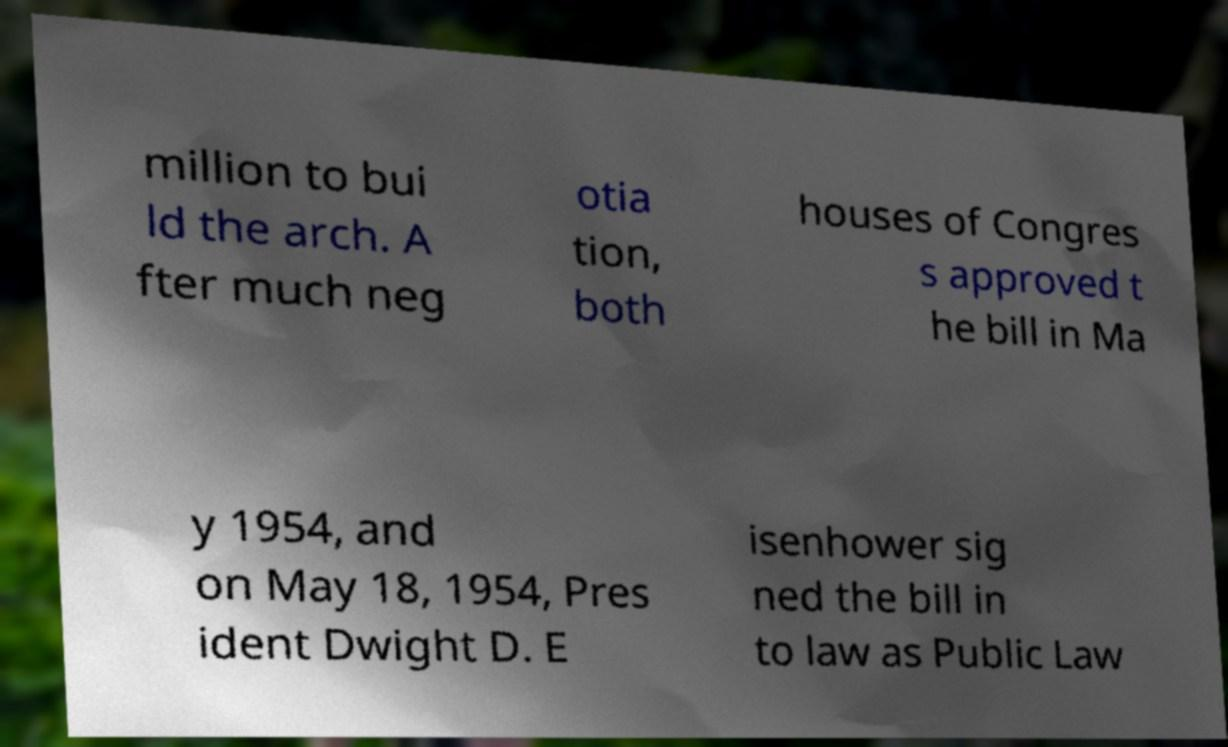Please read and relay the text visible in this image. What does it say? million to bui ld the arch. A fter much neg otia tion, both houses of Congres s approved t he bill in Ma y 1954, and on May 18, 1954, Pres ident Dwight D. E isenhower sig ned the bill in to law as Public Law 